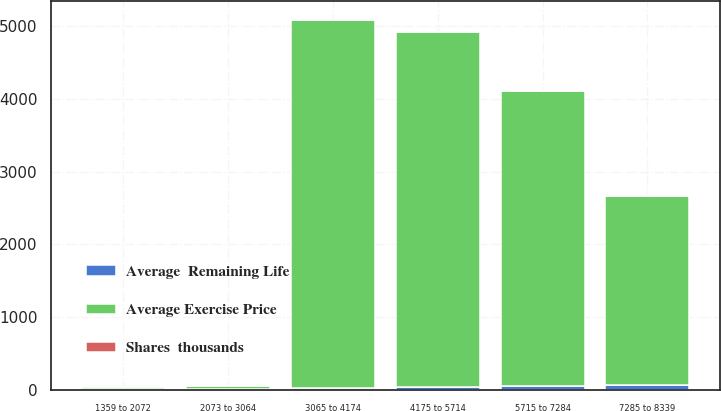Convert chart. <chart><loc_0><loc_0><loc_500><loc_500><stacked_bar_chart><ecel><fcel>1359 to 2072<fcel>2073 to 3064<fcel>3065 to 4174<fcel>4175 to 5714<fcel>5715 to 7284<fcel>7285 to 8339<nl><fcel>Average Exercise Price<fcel>34<fcel>34<fcel>5041<fcel>4857<fcel>4043<fcel>2595<nl><fcel>Average  Remaining Life<fcel>19.85<fcel>24.94<fcel>35.77<fcel>52.32<fcel>63.32<fcel>75.63<nl><fcel>Shares  thousands<fcel>0.4<fcel>3<fcel>5<fcel>7<fcel>8<fcel>10<nl></chart> 